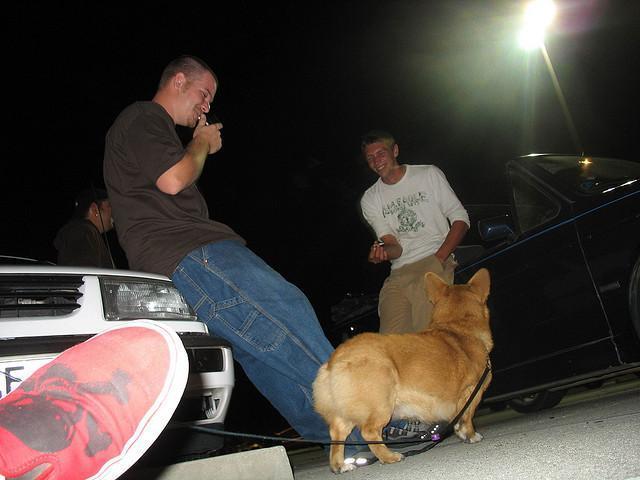How many cars are there?
Give a very brief answer. 2. How many people are in the photo?
Give a very brief answer. 4. How many big elephants are there?
Give a very brief answer. 0. 